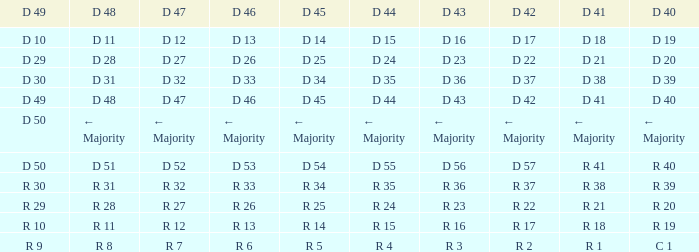Provide the d 49 and d 46 of r 1 R 10. 